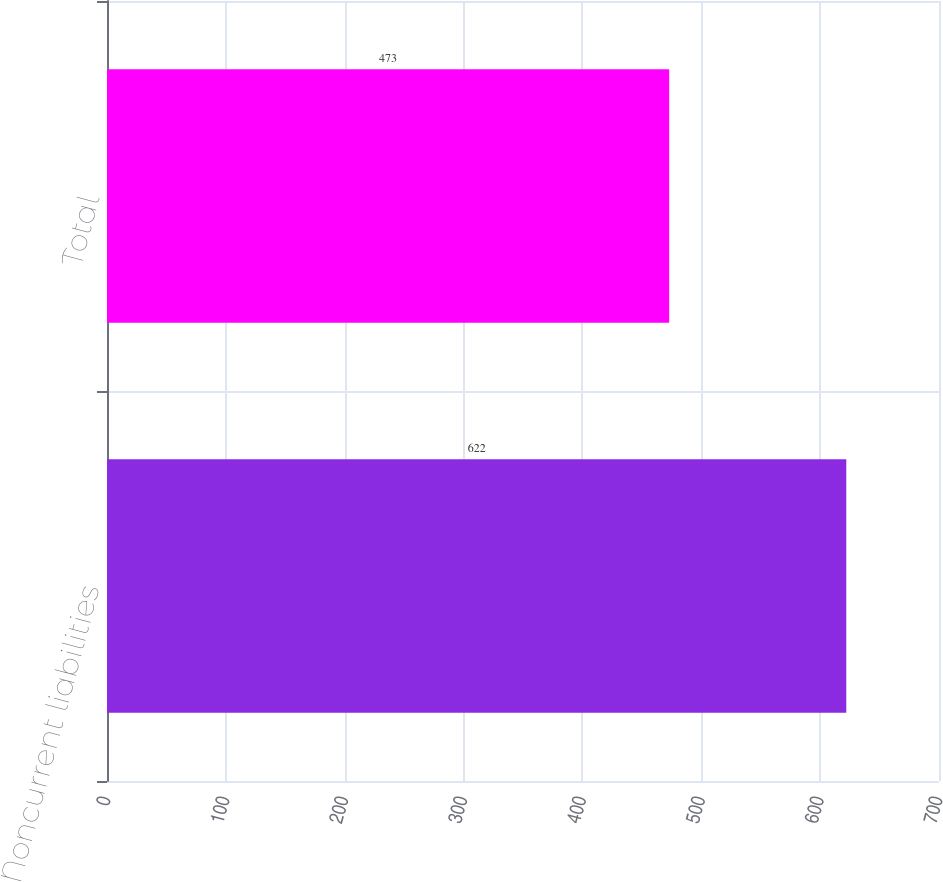Convert chart. <chart><loc_0><loc_0><loc_500><loc_500><bar_chart><fcel>Noncurrent liabilities<fcel>Total<nl><fcel>622<fcel>473<nl></chart> 